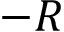Convert formula to latex. <formula><loc_0><loc_0><loc_500><loc_500>- R</formula> 